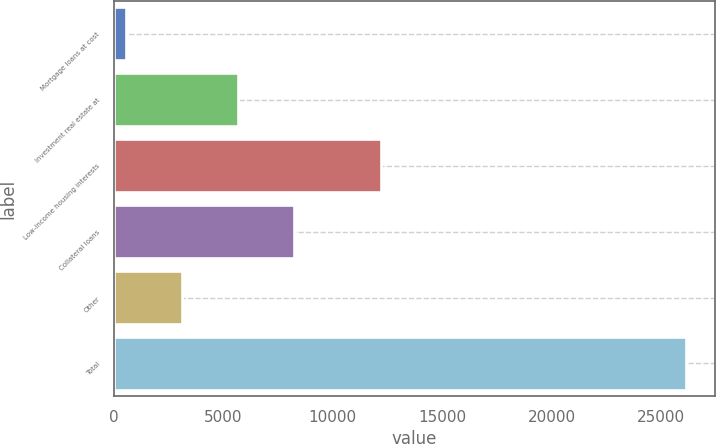Convert chart. <chart><loc_0><loc_0><loc_500><loc_500><bar_chart><fcel>Mortgage loans at cost<fcel>Investment real estate at<fcel>Low-income housing interests<fcel>Collateral loans<fcel>Other<fcel>Total<nl><fcel>551<fcel>5674.2<fcel>12188<fcel>8235.8<fcel>3112.6<fcel>26167<nl></chart> 